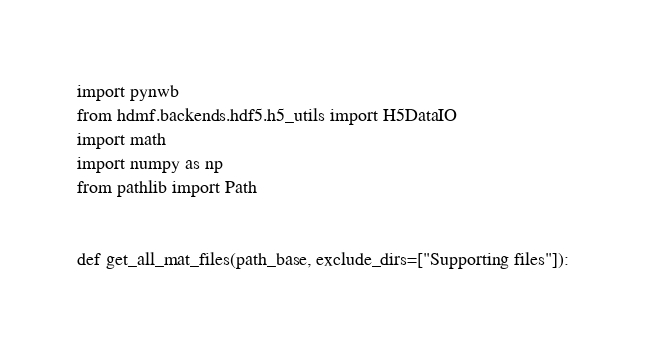Convert code to text. <code><loc_0><loc_0><loc_500><loc_500><_Python_>import pynwb
from hdmf.backends.hdf5.h5_utils import H5DataIO
import math
import numpy as np
from pathlib import Path


def get_all_mat_files(path_base, exclude_dirs=["Supporting files"]):</code> 